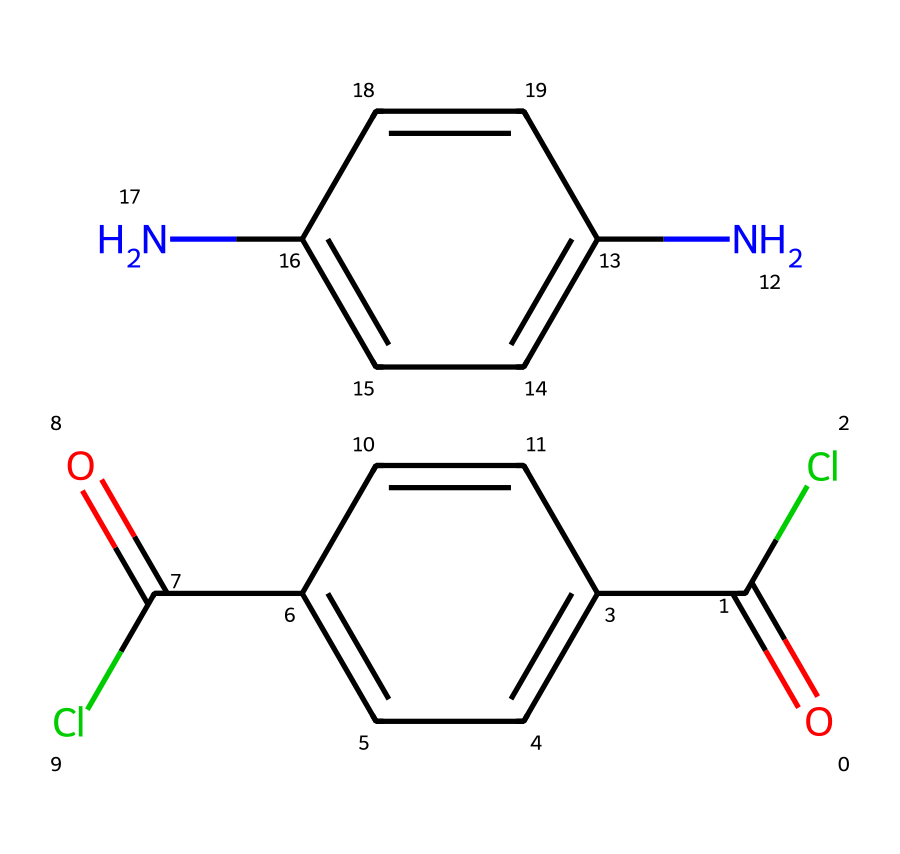What is the molecular formula of the monomer represented? To determine the molecular formula, count the number of each type of atom in the SMILES. There are 12 carbon (C), 10 hydrogen (H), 4 chlorine (Cl), 2 nitrogen (N), and 2 oxygen (O) atoms.
Answer: C12H10Cl4N2O2 How many nitrogen atoms are present in the structure? By inspecting the SMILES representation, there are two occurrences of "N," which indicates the presence of two nitrogen atoms in the structure.
Answer: 2 What type of functional groups are present in this monomer? The structure contains carbonyl groups (C=O) indicated by "O=," amine groups (–NH–) seen with "Nc," and chloro groups (–Cl) which are identified with "Cl" in the SMILES. Combining these, we identify three functional groups.
Answer: carbonyl, amine, chloro Why might this monomer contribute to the strength of Kevlar? The strength of Kevlar arises from strong intermolecular interactions like hydrogen bonding between the amine and carbonyl groups, and the extended conjugation in the aromatic rings. These features provide structural stability and resistance against breakage.
Answer: intermolecular interactions What is the significance of having chlorine atoms in the structure? Chlorine can enhance the thermal stability and fire resistance of the polymer, which is crucial for protective applications like bulletproof vests. Its presence may also improve the barrier properties of the material.
Answer: thermal stability What is the total number of aromatic rings in this monomer? Looking at the structure, there are two distinct aromatic rings identifiable through the alternating double bonds and the placement of nitrogen and chlorine, showcasing their stability in the backbone.
Answer: 2 